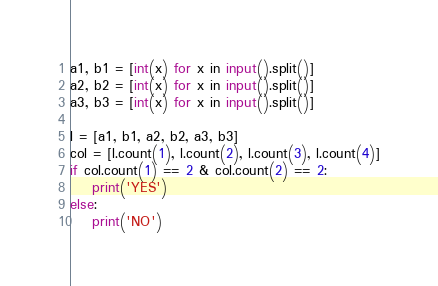Convert code to text. <code><loc_0><loc_0><loc_500><loc_500><_Python_>a1, b1 = [int(x) for x in input().split()]
a2, b2 = [int(x) for x in input().split()]
a3, b3 = [int(x) for x in input().split()]

l = [a1, b1, a2, b2, a3, b3]
col = [l.count(1), l.count(2), l.count(3), l.count(4)]
if col.count(1) == 2 & col.count(2) == 2:
    print('YES')
else:
    print('NO')</code> 